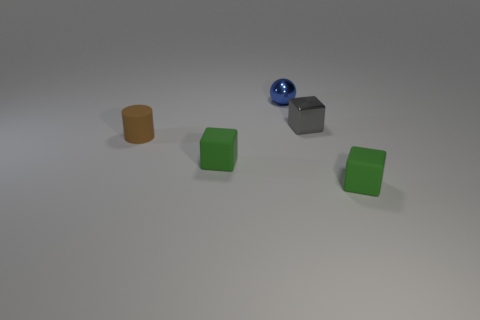Subtract 1 cubes. How many cubes are left? 2 Add 2 brown rubber things. How many objects exist? 7 Subtract all cubes. How many objects are left? 2 Add 1 tiny blue shiny things. How many tiny blue shiny things exist? 2 Subtract 0 gray balls. How many objects are left? 5 Subtract all big brown balls. Subtract all blue metallic objects. How many objects are left? 4 Add 4 brown matte objects. How many brown matte objects are left? 5 